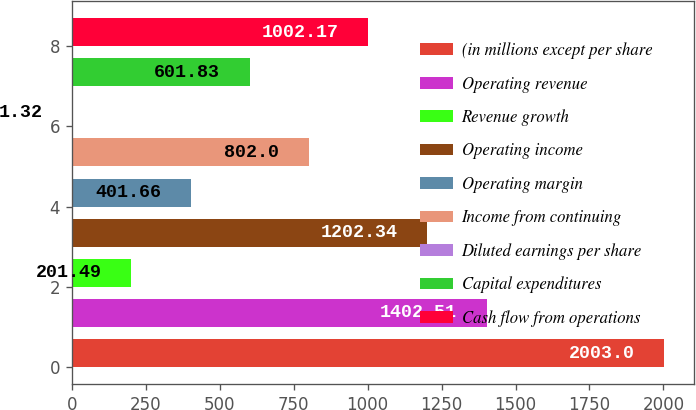Convert chart to OTSL. <chart><loc_0><loc_0><loc_500><loc_500><bar_chart><fcel>(in millions except per share<fcel>Operating revenue<fcel>Revenue growth<fcel>Operating income<fcel>Operating margin<fcel>Income from continuing<fcel>Diluted earnings per share<fcel>Capital expenditures<fcel>Cash flow from operations<nl><fcel>2003<fcel>1402.51<fcel>201.49<fcel>1202.34<fcel>401.66<fcel>802<fcel>1.32<fcel>601.83<fcel>1002.17<nl></chart> 